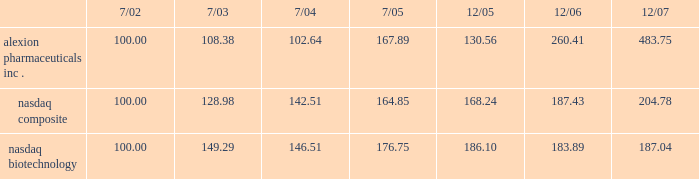The company 2019s stock performance the following graph compares cumulative total return of the company 2019s common stock with the cumulative total return of ( i ) the nasdaq stock market-united states , and ( ii ) the nasdaq biotechnology index .
The graph assumes ( a ) $ 100 was invested on july 31 , 2001 in each of the company 2019s common stock , the stocks comprising the nasdaq stock market-united states and the stocks comprising the nasdaq biotechnology index , and ( b ) the reinvestment of dividends .
Comparison of 65 month cumulative total return* among alexion pharmaceuticals , inc. , the nasdaq composite index and the nasdaq biotechnology index alexion pharmaceuticals , inc .
Nasdaq composite nasdaq biotechnology .

What is the percent change in the investment into alexion pharmaceuticals between 7/02 and 7/03? 
Computations: ((108.38 - 100) / 100)
Answer: 0.0838. 